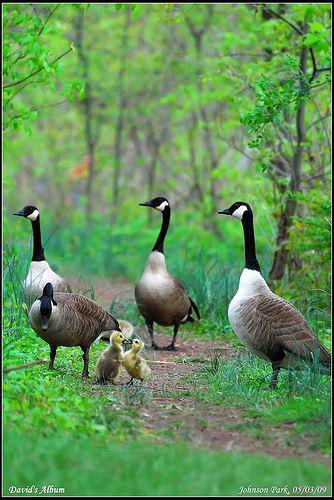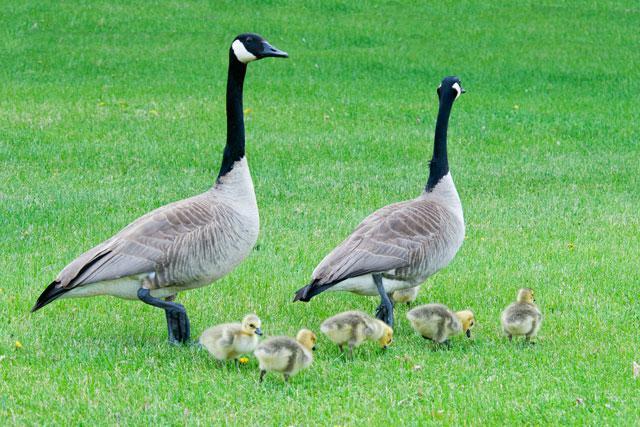The first image is the image on the left, the second image is the image on the right. For the images shown, is this caption "An image shows two adult geese on a grassy field with multiple goslings." true? Answer yes or no. Yes. The first image is the image on the left, the second image is the image on the right. Analyze the images presented: Is the assertion "there are two ducks in the right image." valid? Answer yes or no. No. 